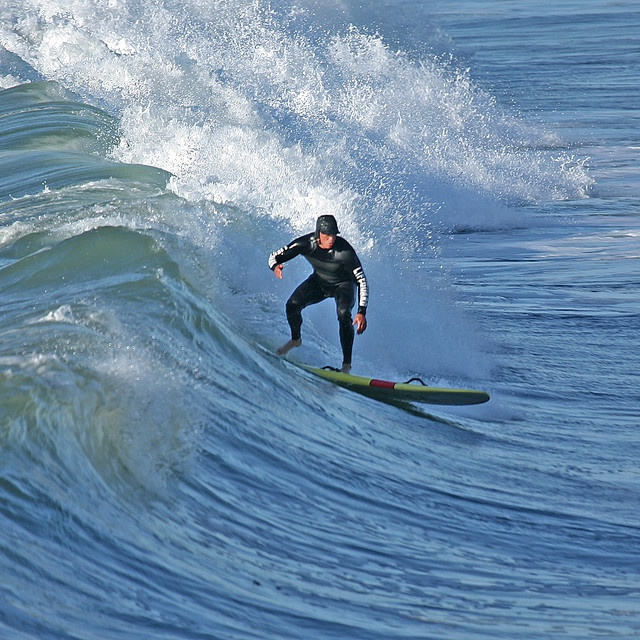Describe the objects in this image and their specific colors. I can see people in darkgray, black, gray, navy, and blue tones, surfboard in darkgray, black, darkblue, blue, and teal tones, and surfboard in darkgray, darkgreen, black, and olive tones in this image. 